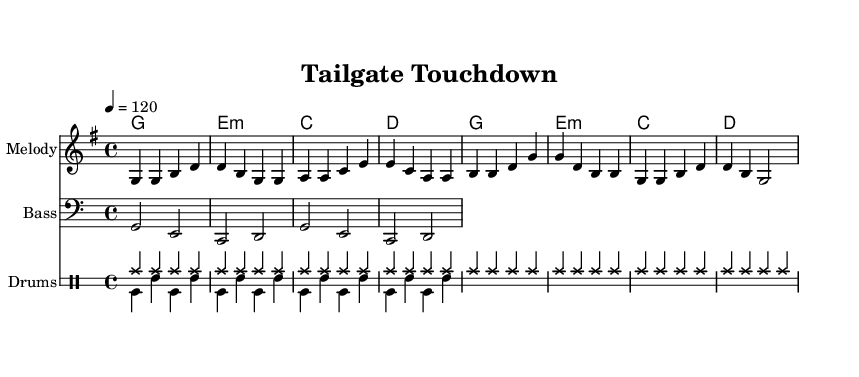What is the key signature of this music? The key signature is G major, which has one sharp, F#. This can be identified from the "g" in the global block indicating the key.
Answer: G major What is the time signature of this music? The time signature is 4/4, meaning there are four beats in each measure. This is clearly indicated by the "4/4" notation in the global block.
Answer: 4/4 What is the tempo marking of this piece? The tempo marking is indicated as "4 = 120", meaning there are 120 quarter-note beats per minute. This is found in the "tempo" line of the global block.
Answer: 120 What are the lyrics of the chorus? The lyrics of the chorus are "Go, go, B. C. Li -- ons! Fight, fight, we're by your side!" This excerpt can be found directly under the chorus statement in the lyrics section.
Answer: Go, go, B.C. Lions! Fight, fight, we're by your side! How many measures are in the melody? The melody consists of eight measures, as indicated by the series of bar lines separating the notes. Counting the divisions shows a total of eight measures.
Answer: 8 What unique rhythmic element is emphasized in the drums? The unique rhythmic element emphasized in the drums is the hi-hat pattern, indicated by repeating hi-hat notes in the drummode section that create a steady pulse throughout.
Answer: Hi-hat pattern What is the overall structure of this piece? The overall structure includes a verse followed by a chorus, creating a typical K-Pop song format that focuses on catchy and memorable sections for sing-alongs. This can be observed in the organization of the lyrics beneath the melodic sections.
Answer: Verse-Chorus 